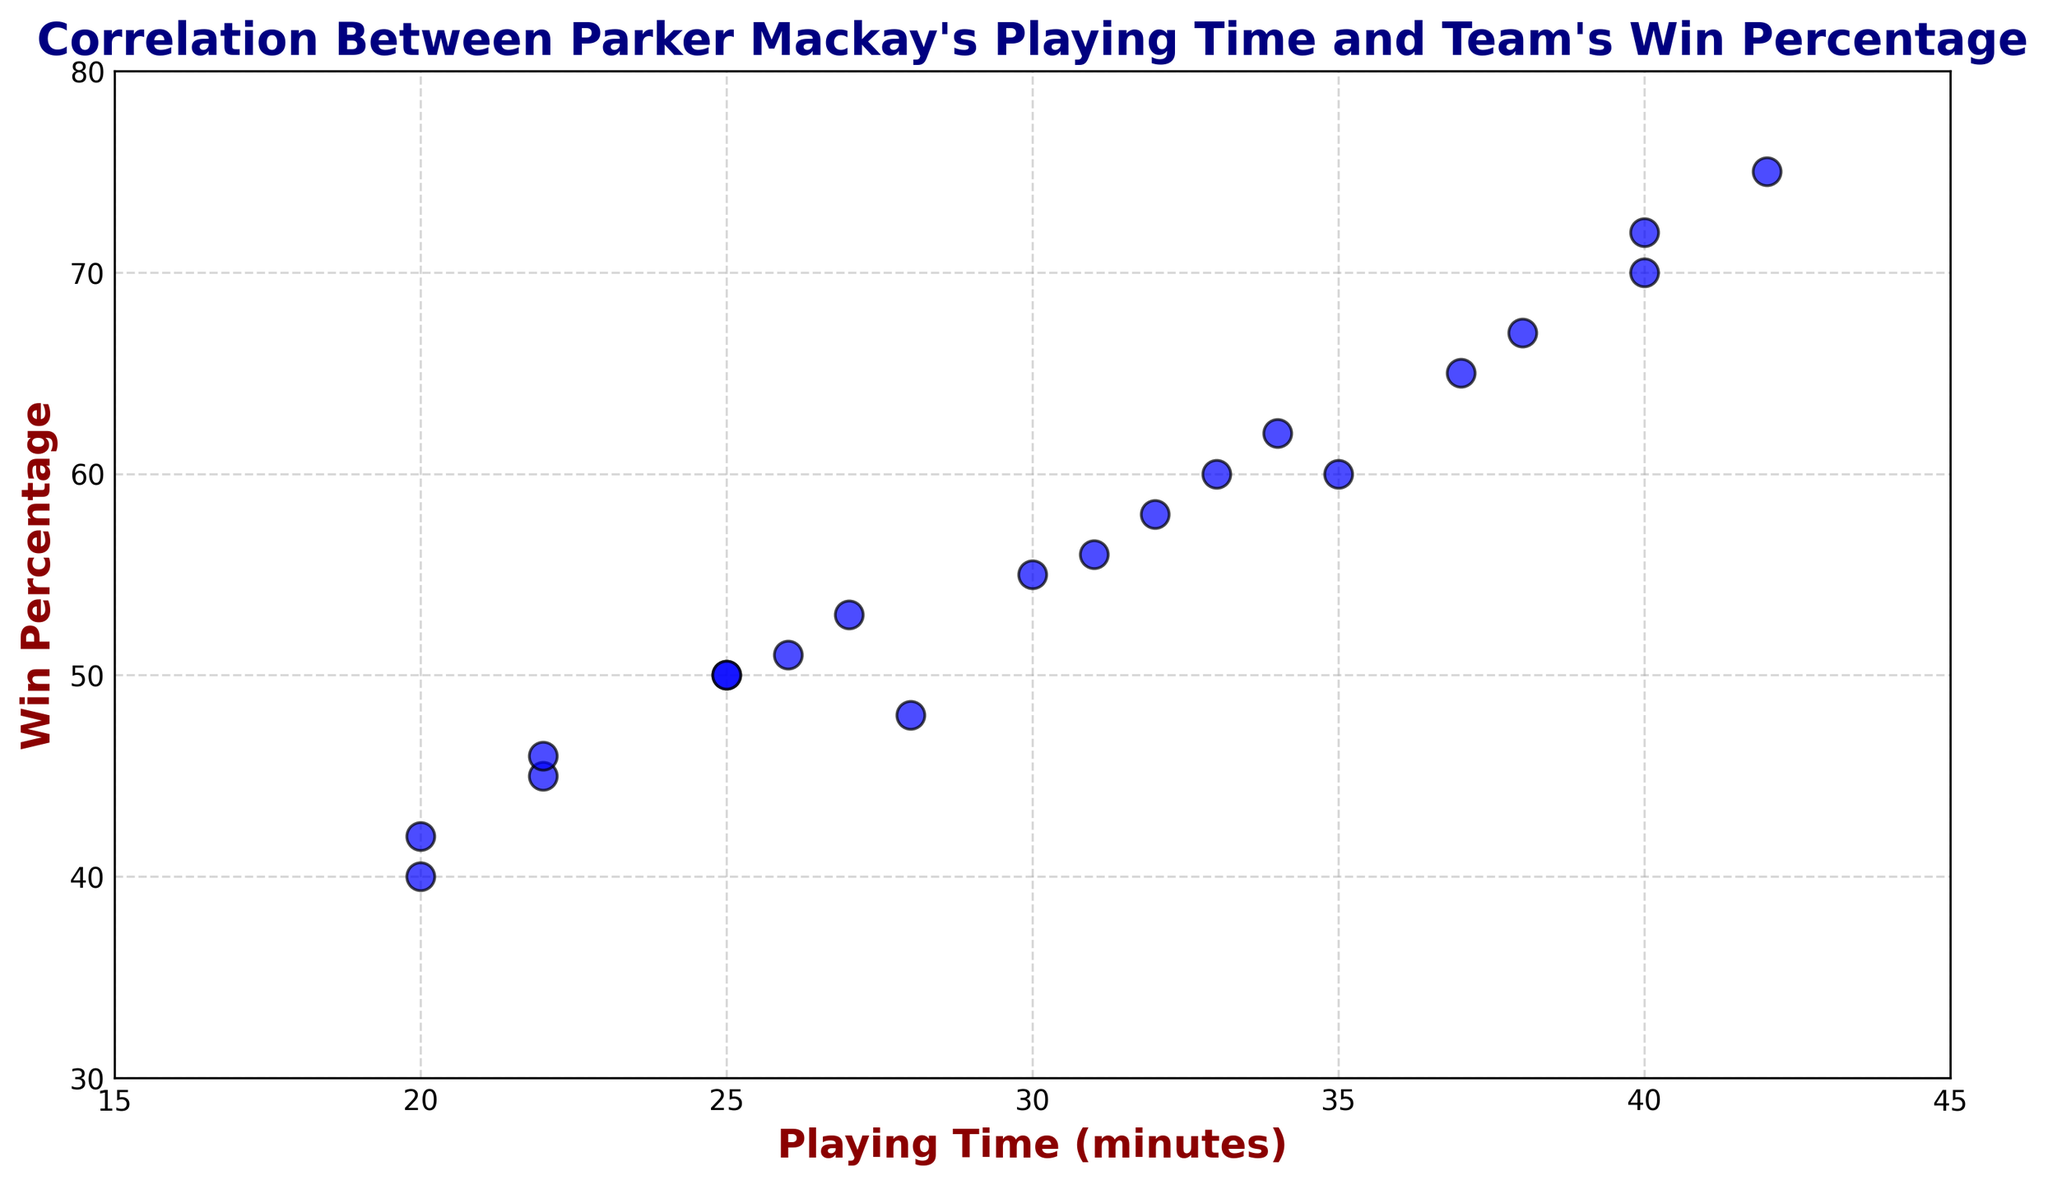Which point has the highest win percentage? To identify the point with the highest win percentage, look at the y-axis and find the point with the highest value. The highest point on the y-axis is 75.
Answer: (42, 75) What is the range of Parker Mackay's playing time? The range is the difference between the maximum and minimum values on the x-axis. The maximum playing time is 42 minutes and the minimum is 20 minutes. So, the range is 42 - 20 = 22 minutes.
Answer: 22 minutes By how much does the win percentage increase when Parker Mackay's playing time increases from 20 to 40 minutes? Find the win percentages corresponding to 20 and 40 minutes from the scatter plot. At 20 minutes, the win percentage is around 40-42%, and at 40 minutes, it is around 70-72%. The difference is approximately 72 - 42 = 30 percentage points.
Answer: 30 percentage points Is there a general trend that shows an increase in win percentage with more playing time? Observe the overall pattern in the scatter plot. Most points show an upward trend as playing time increases, which indicates a positive correlation between playing time and win percentage.
Answer: Yes Which playing time duration has the most outliers compared to the general trend? Visually examine the scatter plot and identify any points that are significantly distant from the general trend line. The playing times of 28 minutes and 38 minutes have a sharper deviation from the trend.
Answer: 28 and 38 minutes What is the median win percentage for Parker Mackay's playing times shown in the plot? Arrange the win percentages in ascending order and find the middle value. There are 20 data points, so the median will be the average of the 10th and 11th values. The values at these positions are 50 and 51, so the median is (50 + 51) / 2 = 50.5%.
Answer: 50.5% How does the win percentage change when Parker Mackay’s playing time shifts from 22 to 37 minutes? Compare the win percentages corresponding to 22 and 37 minutes. At 22 minutes, the win percentage is approximately 45-46%, and at 37 minutes, it is around 65%. The change is 65 - 46 = 19 percentage points.
Answer: 19 percentage points What is the average win percentage across all playing times shown in the scatter plot? Add all the win percentages and then divide by the number of data points. The sum of the win percentages is (40+45+50+55+48+60+70+67+58+50+53+62+72+65+42+46+51+56+60+75) = 1025. Dividing this sum by the number of data points (20) gives an average of 1025 / 20 = 51.25%.
Answer: 51.25% Do any points share the same win percentage but have different playing times? Look for points on the scatter plot that align horizontally. Points at (25, 50) and (25, 50) share the same win percentage (50%) but have different playing times (25 minutes and another point around 26 minutes).
Answer: Yes What is the difference between the maximum and minimum win percentages in the scatter plot? Find the highest and lowest points on the y-axis. The highest win percentage is 75%, and the lowest is 40%. The difference is 75 - 40 = 35 percentage points.
Answer: 35 percentage points 